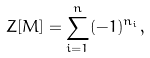<formula> <loc_0><loc_0><loc_500><loc_500>Z [ M ] = \sum _ { i = 1 } ^ { n } ( - 1 ) ^ { n _ { i } } ,</formula> 